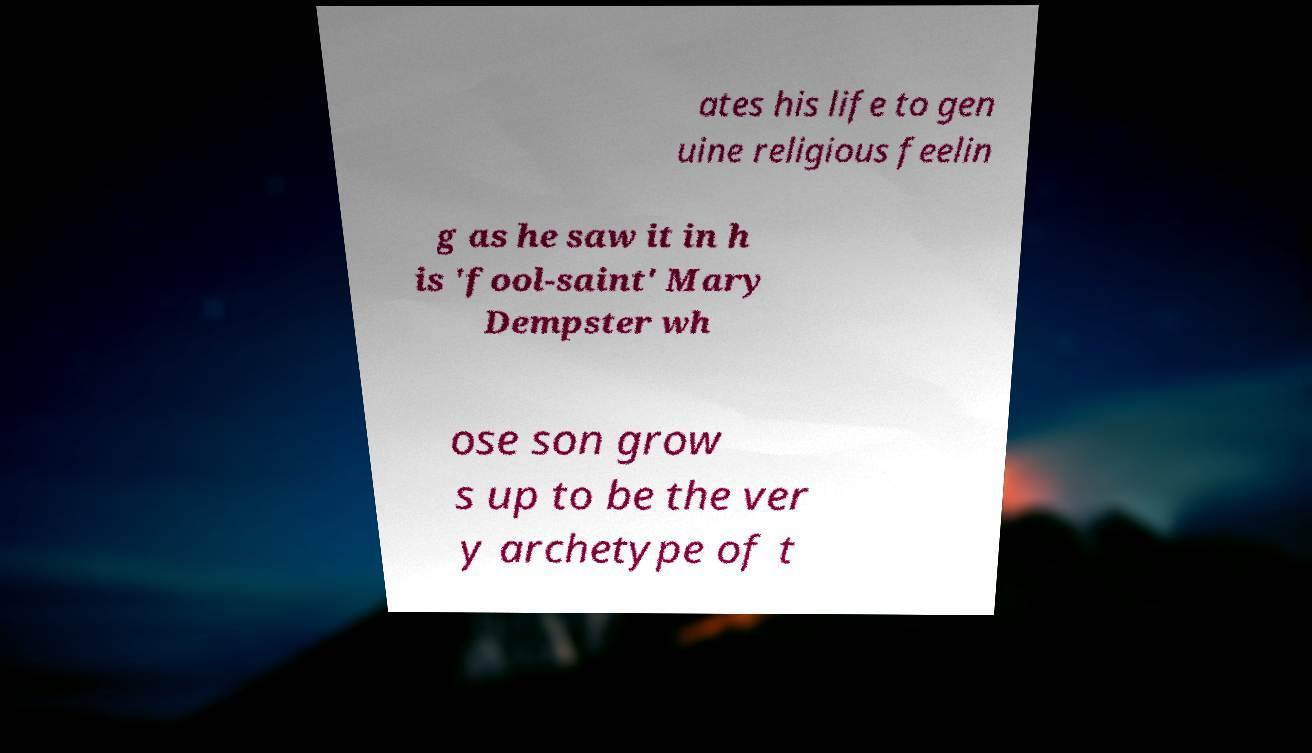I need the written content from this picture converted into text. Can you do that? ates his life to gen uine religious feelin g as he saw it in h is 'fool-saint' Mary Dempster wh ose son grow s up to be the ver y archetype of t 